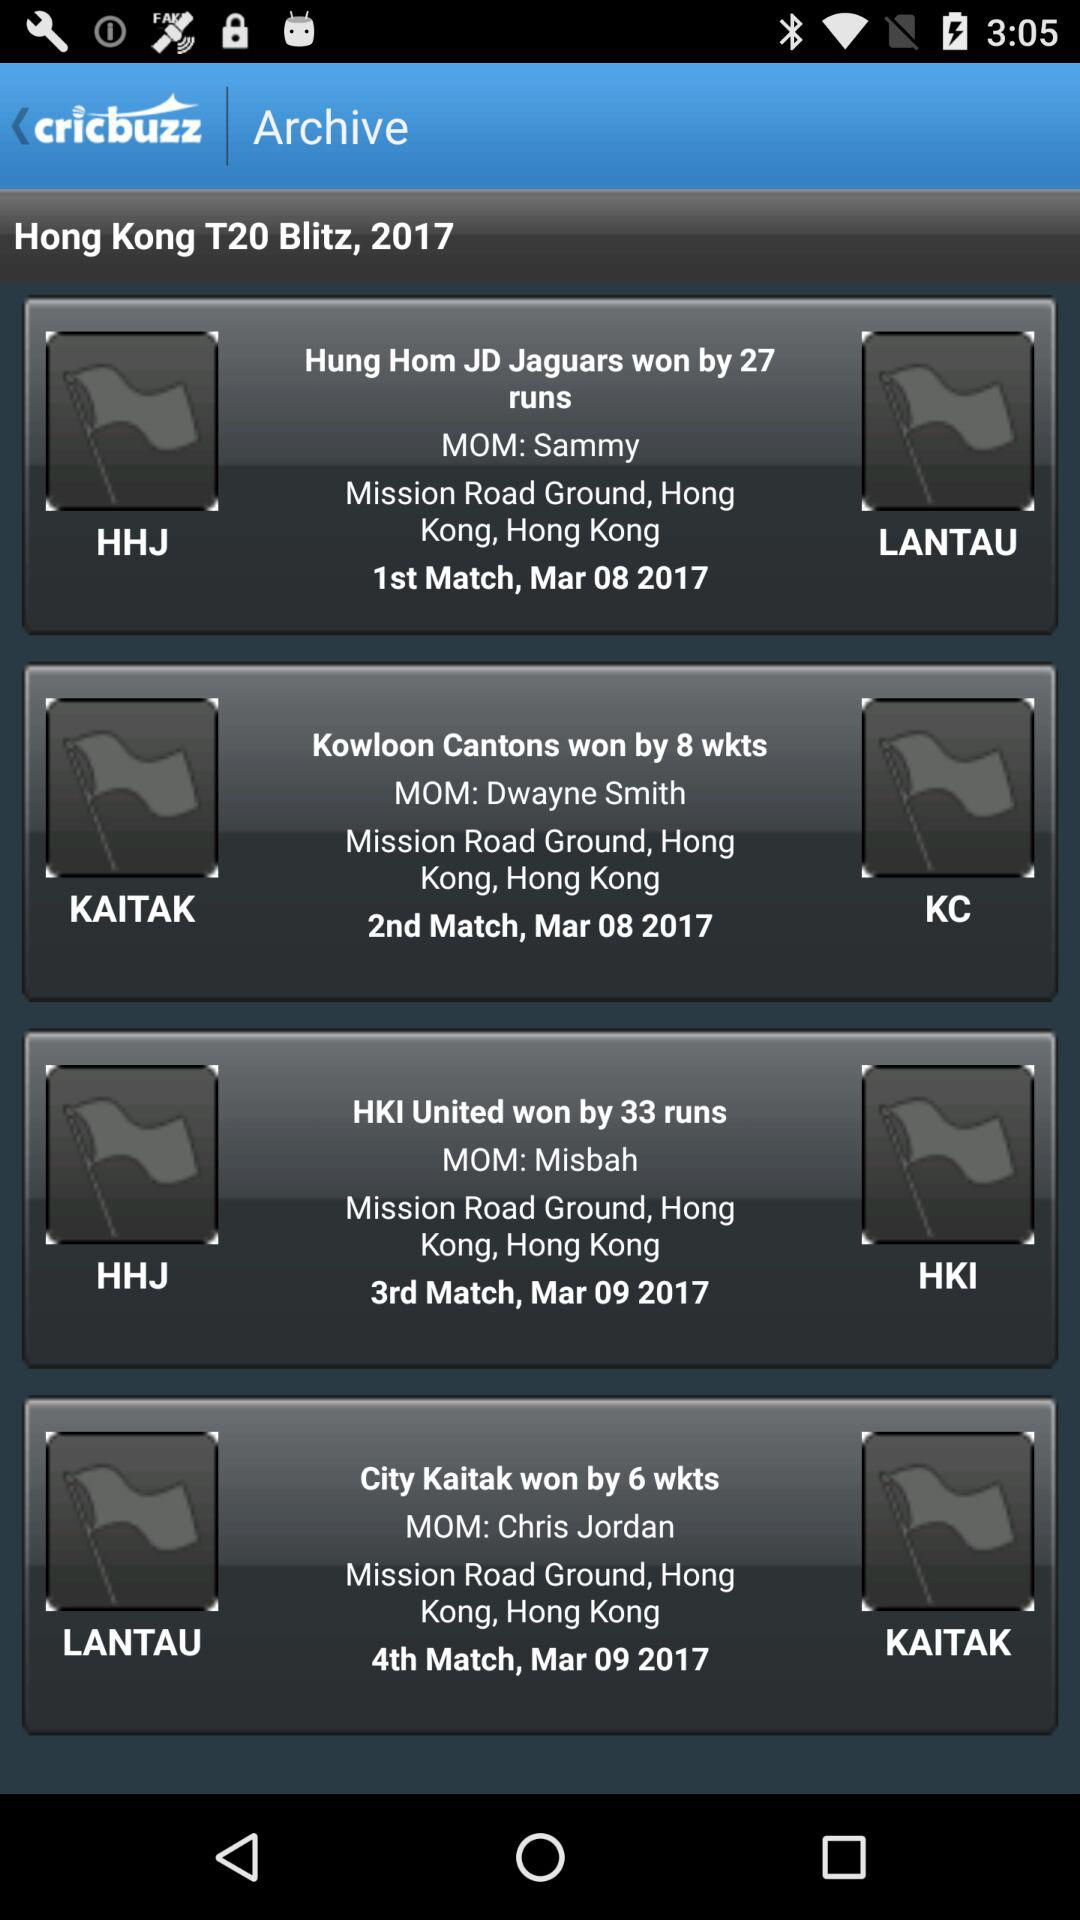At which place was the 3rd match played? The 3rd match was played at Mission Road Ground, Hong Kong. 